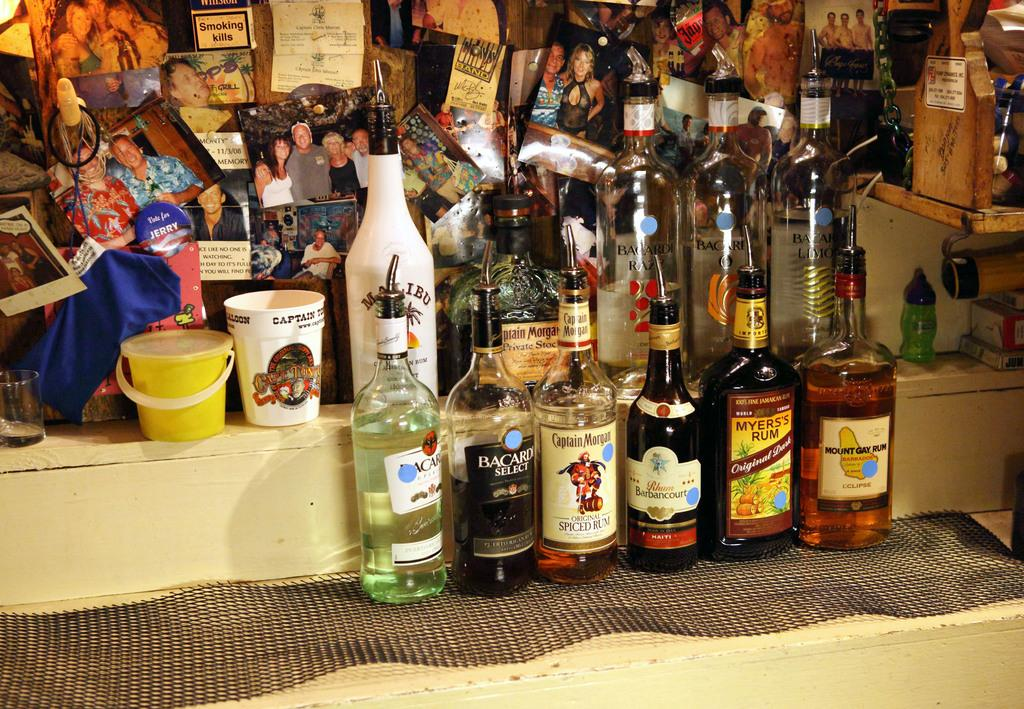<image>
Give a short and clear explanation of the subsequent image. a myers's rum bottle that has liquid in it 